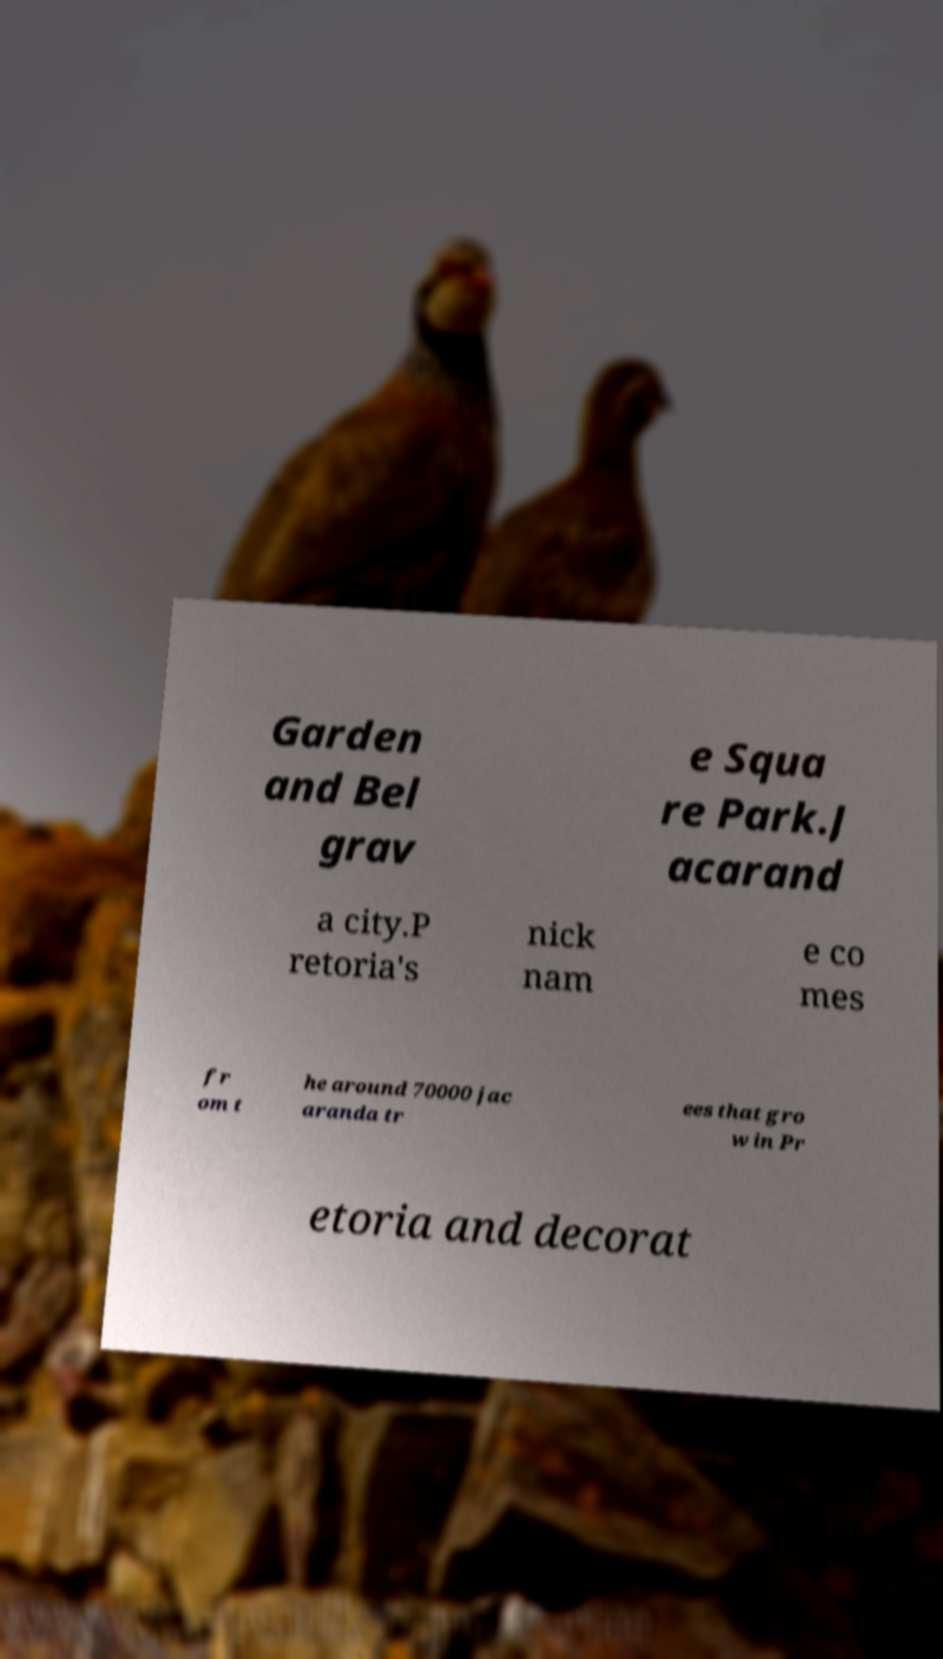For documentation purposes, I need the text within this image transcribed. Could you provide that? Garden and Bel grav e Squa re Park.J acarand a city.P retoria's nick nam e co mes fr om t he around 70000 jac aranda tr ees that gro w in Pr etoria and decorat 